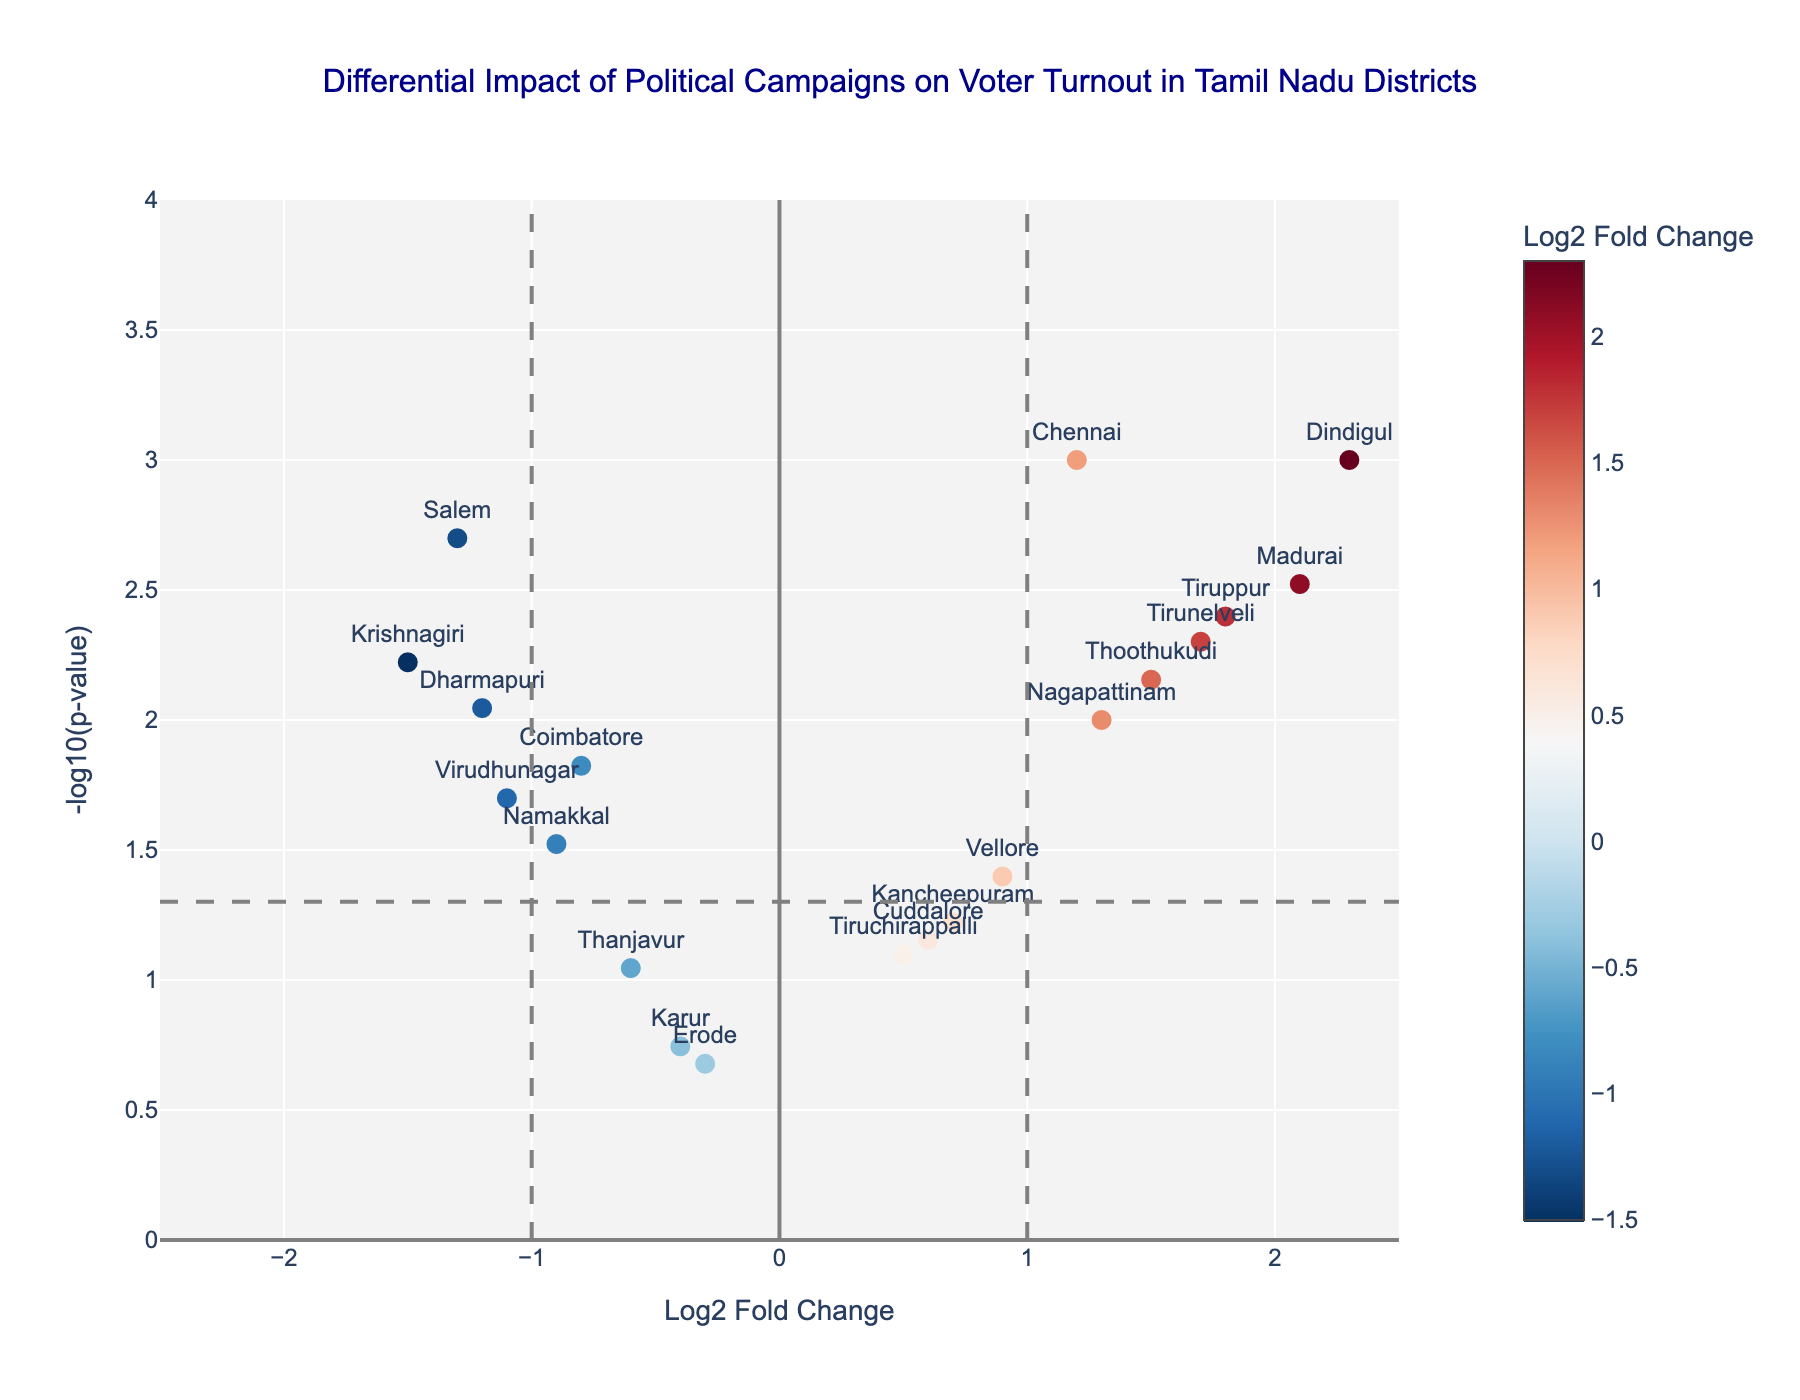What is the title of the figure? The title of the figure is prominently displayed at the top of the plot. It reads: "Differential Impact of Political Campaigns on Voter Turnout in Tamil Nadu Districts".
Answer: Differential Impact of Political Campaigns on Voter Turnout in Tamil Nadu Districts How many districts have a Log2 Fold Change greater than 1? By examining the x-axis (Log2 Fold Change) and counting all data points positioned to the right of the vertical line at x=1, we find the following districts: Madurai, Tirunelveli, Thoothukudi, Dindigul, Tiruppur, and Nagapattinam.
Answer: 6 Which district has the smallest p-value and what is its Log2 Fold Change? From the hover information on the graph or directly checking the table, we see that Chennai has the smallest p-value (0.001), and its corresponding Log2 Fold Change is 1.2.
Answer: Chennai, 1.2 Are there any districts with both a negative Log2 Fold Change and a p-value less than 0.05? By looking at the points on the left of the plot (negative Log2 Fold Change) and below the horizontal line indicating p-value < 0.05 (-log10(0.05) approximately 1.301), we identify Coimbatore, Salem, Virudhunagar, Namakkal, Krishnagiri, and Dharmapuri.
Answer: Yes Which districts are considered statistically significant at the p-value threshold of 0.05? All districts with data points located above the horizontal line at -log10(p-value) of approximately 1.301 are considered significant. These include Chennai, Coimbatore, Madurai, Salem, Tirunelveli, Thoothukudi, Dindigul, Virudhunagar, Vellore, Namakkal, Tiruppur, Nagapattinam, Krishnagiri, and Dharmapuri.
Answer: 14 districts What is the highest Log2 Fold Change observed and which district does it correspond to? By identifying the point furthest to the right on the x-axis (Log2 Fold Change), we see that Dindigul has the highest value of 2.3.
Answer: Dindigul, 2.3 How many districts have both a Log2 Fold Change between -1 and 1 and a non-significant p-value (> 0.05)? By inspecting the plot for points within the range of -1 and 1 on the x-axis and below the horizontal line of -log10(p-value) of approximately 1.301, we count the districts: Tiruchirappalli, Erode, Thanjavur, Kancheepuram, Cuddalore, and Karur.
Answer: 6 Which district has the most substantial negative impact (lowest Log2 Fold Change) and is it statistically significant? By spotting the lowest Log2 Fold Change on the left and verifying its significance (above the horizontal line), Krishnagiri has the lowest value of -1.5 with a p-value of 0.006, indicating it's significant.
Answer: Krishnagiri, Yes What trends can be observed regarding districts with positive Log2 Fold Changes in the plot? Notably, districts with positive Log2 Fold Changes generally exhibit higher levels of significance (above the horizontal line), indicating a pronounced positive impact of political campaigns on voter turnout in these regions.
Answer: Positive changes show higher significance Compare the Log2 Fold Changes of Chennai and Salem. Which district shows a stronger effect, and in what direction? The Log2 Fold Change for Chennai is 1.2, and for Salem, it is -1.3. Comparing the magnitudes, Salem shows a slightly stronger (more negative) impact compared to the positive impact of Chennai.
Answer: Salem, negative direction 